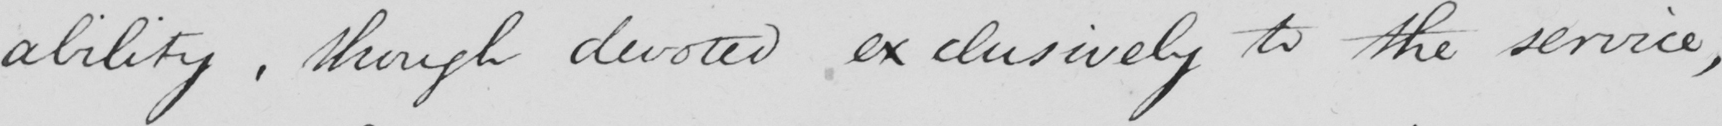Please provide the text content of this handwritten line. ability , though devoted exclusively to the service , 